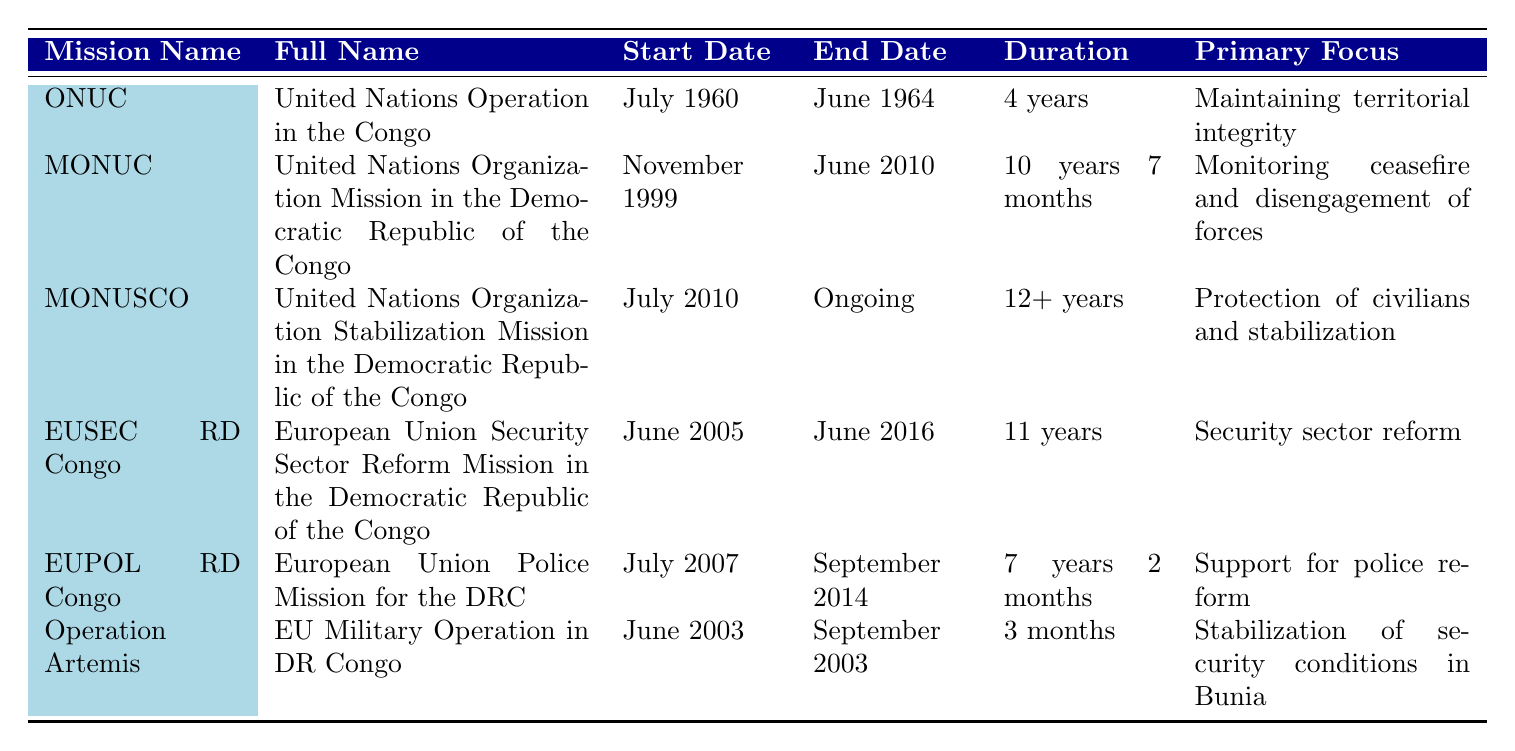What are the start dates of the missions listed? By examining the "Start Date" column in the table, we can see that the start dates for each mission are: ONUC - July 1960, MONUC - November 1999, MONUSCO - July 2010, EUSEC RD Congo - June 2005, EUPOL RD Congo - July 2007, Operation Artemis - June 2003.
Answer: July 1960, November 1999, July 2010, June 2005, July 2007, June 2003 Which mission has the longest duration? To determine the longest duration, we compare the duration values: ONUC (4 years), MONUC (10 years 7 months), MONUSCO (12+ years), EUSEC RD Congo (11 years), EUPOL RD Congo (7 years 2 months), and Operation Artemis (3 months). MONUSCO has the longest duration as it is ongoing and has lasted over 12 years.
Answer: MONUSCO Was the Operation Artemis mission longer than 2 months? Checking the duration of Operation Artemis, which is listed as 3 months, confirms that it lasted longer than 2 months.
Answer: Yes How many missions focused on security and stabilization? The missions focusing on security and stabilization are MONUSCO (Protection of civilians and stabilization), EUSEC RD Congo (Security sector reform), and Operation Artemis (Stabilization of security conditions in Bunia). There are a total of three missions fitting this criterion.
Answer: 3 What is the total duration of all missions combined? Summing the duration values involves converting them to months: ONUC (48), MONUC (127), MONUSCO (12+, considering 12 months as a minimum for this calculation), EUSEC RD Congo (132), EUPOL RD Congo (86), Operation Artemis (3). Totaling these gives 48 + 127 + 12 + 132 + 86 + 3 = 408 months, which is 34 years.
Answer: 34 years When did the EUSEC RD Congo mission start relative to the MONUSCO mission? EUSEC RD Congo started in June 2005 while MONUSCO started in July 2010. Therefore, EUSEC RD Congo began 5 years before MONUSCO started.
Answer: 5 years earlier What was the primary focus of the MONUC mission? Referring to the Primary Focus column, the primary focus of the MONUC mission is listed as "Monitoring ceasefire and disengagement of forces."
Answer: Monitoring ceasefire and disengagement of forces Has any mission started after 2000? By checking the "Start Date," we see that MONUSCO (July 2010), EUSEC RD Congo (June 2005), EUPOL RD Congo (July 2007), and Operation Artemis (June 2003) all started after 2000. Thus, there are missions that began after that year.
Answer: Yes Which mission lasted for exactly 4 years? Examining the duration for all missions, we find that ONUC had a duration of 4 years exactly, as noted in the Duration column of the table.
Answer: ONUC 